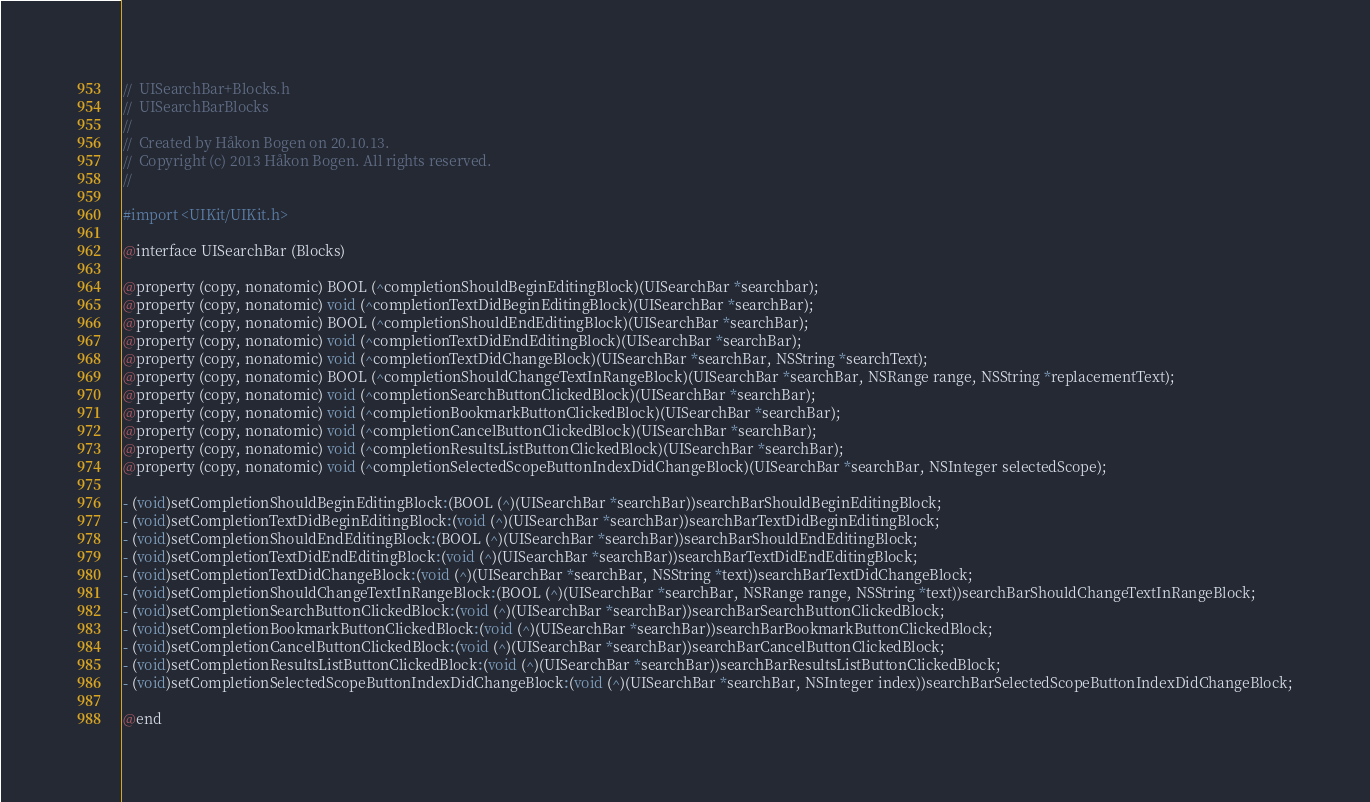Convert code to text. <code><loc_0><loc_0><loc_500><loc_500><_C_>//  UISearchBar+Blocks.h
//  UISearchBarBlocks
//
//  Created by Håkon Bogen on 20.10.13.
//  Copyright (c) 2013 Håkon Bogen. All rights reserved.
//

#import <UIKit/UIKit.h>

@interface UISearchBar (Blocks)

@property (copy, nonatomic) BOOL (^completionShouldBeginEditingBlock)(UISearchBar *searchbar);
@property (copy, nonatomic) void (^completionTextDidBeginEditingBlock)(UISearchBar *searchBar);
@property (copy, nonatomic) BOOL (^completionShouldEndEditingBlock)(UISearchBar *searchBar);
@property (copy, nonatomic) void (^completionTextDidEndEditingBlock)(UISearchBar *searchBar);
@property (copy, nonatomic) void (^completionTextDidChangeBlock)(UISearchBar *searchBar, NSString *searchText);
@property (copy, nonatomic) BOOL (^completionShouldChangeTextInRangeBlock)(UISearchBar *searchBar, NSRange range, NSString *replacementText);
@property (copy, nonatomic) void (^completionSearchButtonClickedBlock)(UISearchBar *searchBar);
@property (copy, nonatomic) void (^completionBookmarkButtonClickedBlock)(UISearchBar *searchBar);
@property (copy, nonatomic) void (^completionCancelButtonClickedBlock)(UISearchBar *searchBar);
@property (copy, nonatomic) void (^completionResultsListButtonClickedBlock)(UISearchBar *searchBar);
@property (copy, nonatomic) void (^completionSelectedScopeButtonIndexDidChangeBlock)(UISearchBar *searchBar, NSInteger selectedScope);

- (void)setCompletionShouldBeginEditingBlock:(BOOL (^)(UISearchBar *searchBar))searchBarShouldBeginEditingBlock;
- (void)setCompletionTextDidBeginEditingBlock:(void (^)(UISearchBar *searchBar))searchBarTextDidBeginEditingBlock;
- (void)setCompletionShouldEndEditingBlock:(BOOL (^)(UISearchBar *searchBar))searchBarShouldEndEditingBlock;
- (void)setCompletionTextDidEndEditingBlock:(void (^)(UISearchBar *searchBar))searchBarTextDidEndEditingBlock;
- (void)setCompletionTextDidChangeBlock:(void (^)(UISearchBar *searchBar, NSString *text))searchBarTextDidChangeBlock;
- (void)setCompletionShouldChangeTextInRangeBlock:(BOOL (^)(UISearchBar *searchBar, NSRange range, NSString *text))searchBarShouldChangeTextInRangeBlock;
- (void)setCompletionSearchButtonClickedBlock:(void (^)(UISearchBar *searchBar))searchBarSearchButtonClickedBlock;
- (void)setCompletionBookmarkButtonClickedBlock:(void (^)(UISearchBar *searchBar))searchBarBookmarkButtonClickedBlock;
- (void)setCompletionCancelButtonClickedBlock:(void (^)(UISearchBar *searchBar))searchBarCancelButtonClickedBlock;
- (void)setCompletionResultsListButtonClickedBlock:(void (^)(UISearchBar *searchBar))searchBarResultsListButtonClickedBlock;
- (void)setCompletionSelectedScopeButtonIndexDidChangeBlock:(void (^)(UISearchBar *searchBar, NSInteger index))searchBarSelectedScopeButtonIndexDidChangeBlock;

@end
</code> 